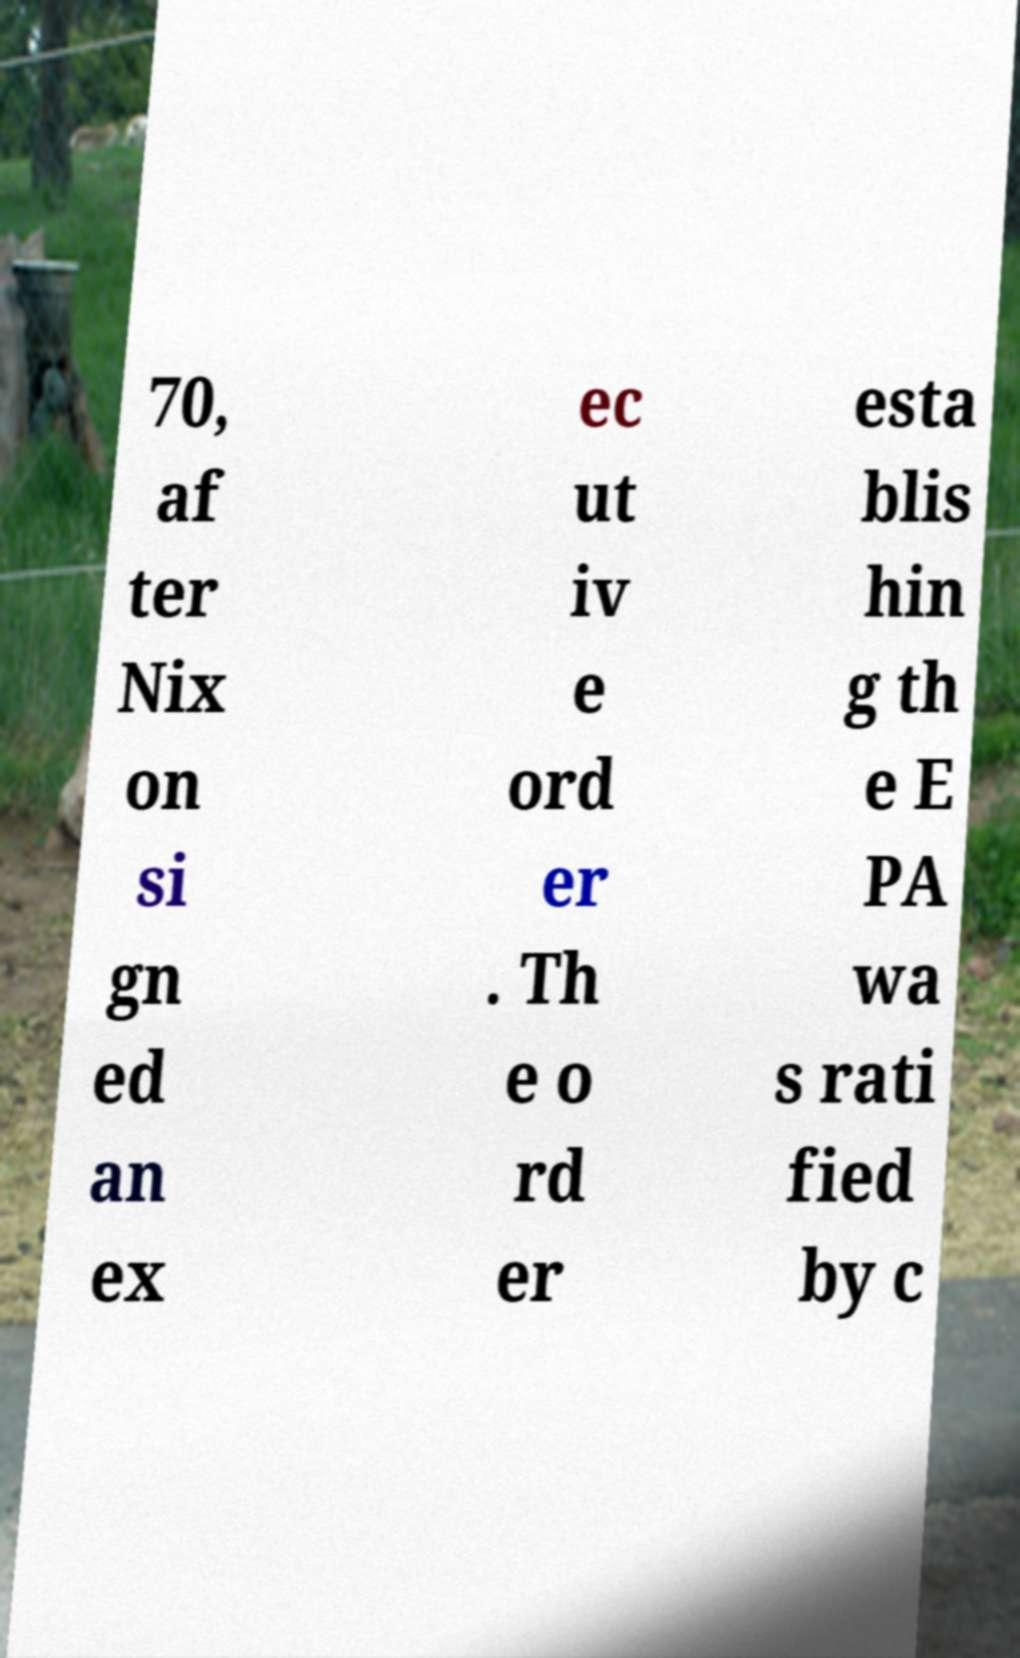Please read and relay the text visible in this image. What does it say? 70, af ter Nix on si gn ed an ex ec ut iv e ord er . Th e o rd er esta blis hin g th e E PA wa s rati fied by c 